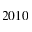<formula> <loc_0><loc_0><loc_500><loc_500>2 0 1 0</formula> 